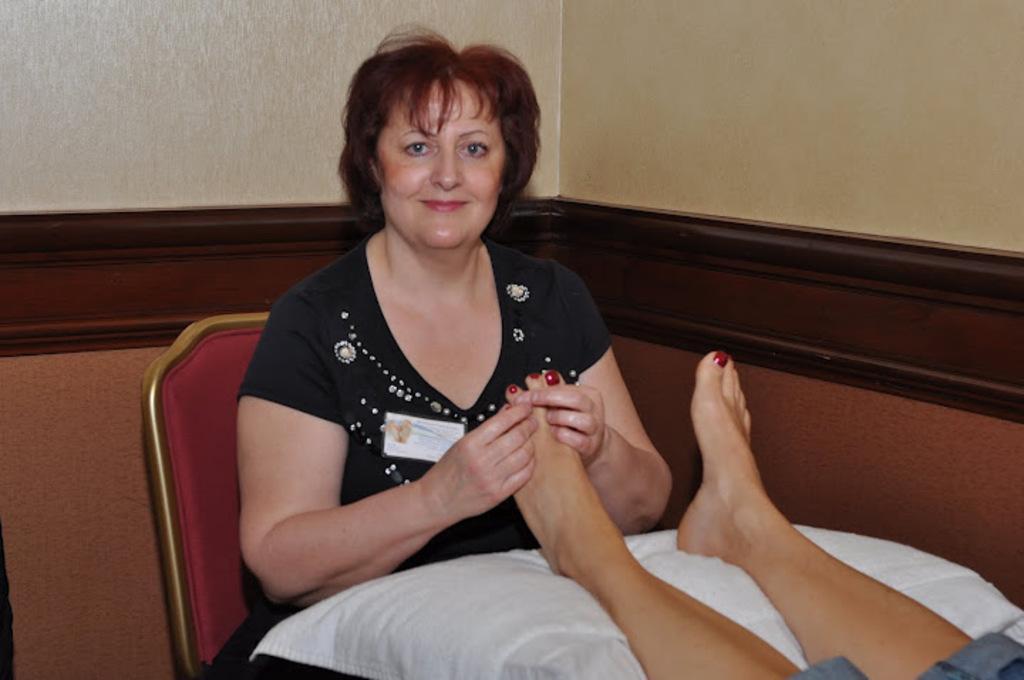Please provide a concise description of this image. This image is taken indoors. In the background there is a wall. In the middle of the image a women is sitting on the chair and she is holding a leg of a person in her hands. She is with a smiling face. On the right side of the image a person is lying on the bed. 